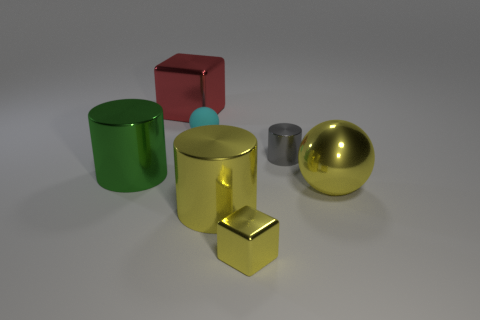Subtract all big metal cylinders. How many cylinders are left? 1 Subtract all cylinders. How many objects are left? 4 Add 1 metal things. How many objects exist? 8 Subtract all gray cylinders. How many cylinders are left? 2 Subtract 1 cylinders. How many cylinders are left? 2 Subtract 0 gray balls. How many objects are left? 7 Subtract all yellow cubes. Subtract all cyan cylinders. How many cubes are left? 1 Subtract all large red metal cubes. Subtract all yellow metallic cylinders. How many objects are left? 5 Add 6 small rubber things. How many small rubber things are left? 7 Add 4 blue things. How many blue things exist? 4 